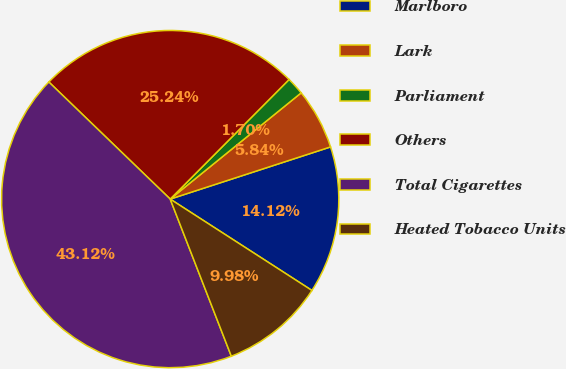<chart> <loc_0><loc_0><loc_500><loc_500><pie_chart><fcel>Marlboro<fcel>Lark<fcel>Parliament<fcel>Others<fcel>Total Cigarettes<fcel>Heated Tobacco Units<nl><fcel>14.12%<fcel>5.84%<fcel>1.7%<fcel>25.24%<fcel>43.12%<fcel>9.98%<nl></chart> 